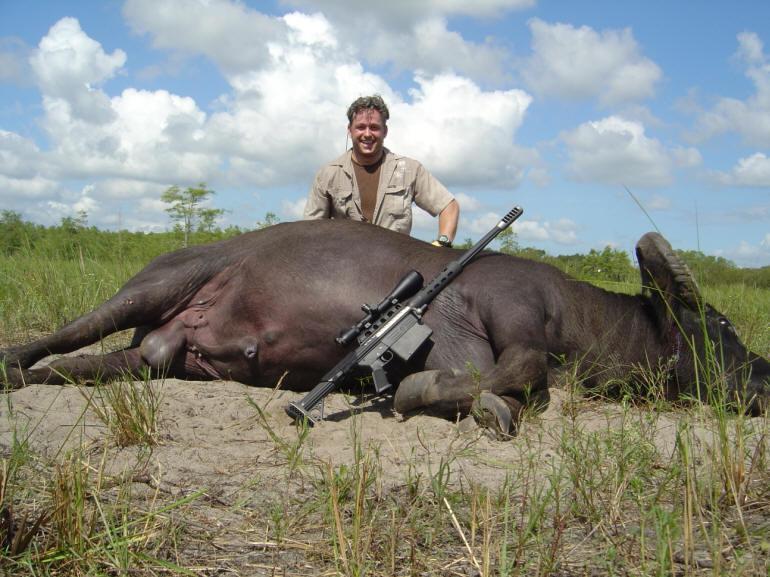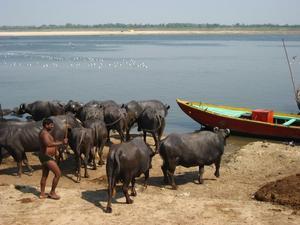The first image is the image on the left, the second image is the image on the right. For the images shown, is this caption "Right image shows one ox with a rope looped through its nose, walking in water." true? Answer yes or no. No. The first image is the image on the left, the second image is the image on the right. Considering the images on both sides, is "At least one water buffalo is standing in water." valid? Answer yes or no. No. 